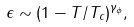<formula> <loc_0><loc_0><loc_500><loc_500>\epsilon \sim ( 1 - T / T _ { c } ) ^ { \gamma _ { \phi } } ,</formula> 